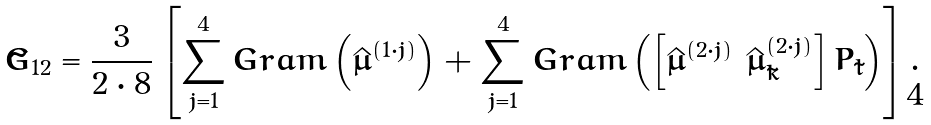<formula> <loc_0><loc_0><loc_500><loc_500>\tilde { G } _ { 1 2 } = \frac { 3 } { 2 \cdot 8 } \left [ \sum _ { j = 1 } ^ { 4 } G r a m \left ( \hat { \mu } ^ { ( 1 \cdot j ) } \right ) + \sum _ { j = 1 } ^ { 4 } G r a m \left ( \left [ \hat { \mu } ^ { ( 2 \cdot j ) } \ \hat { \mu } _ { \tilde { k } } ^ { ( 2 \cdot j ) } \right ] P _ { \tilde { l } } \right ) \right ] .</formula> 